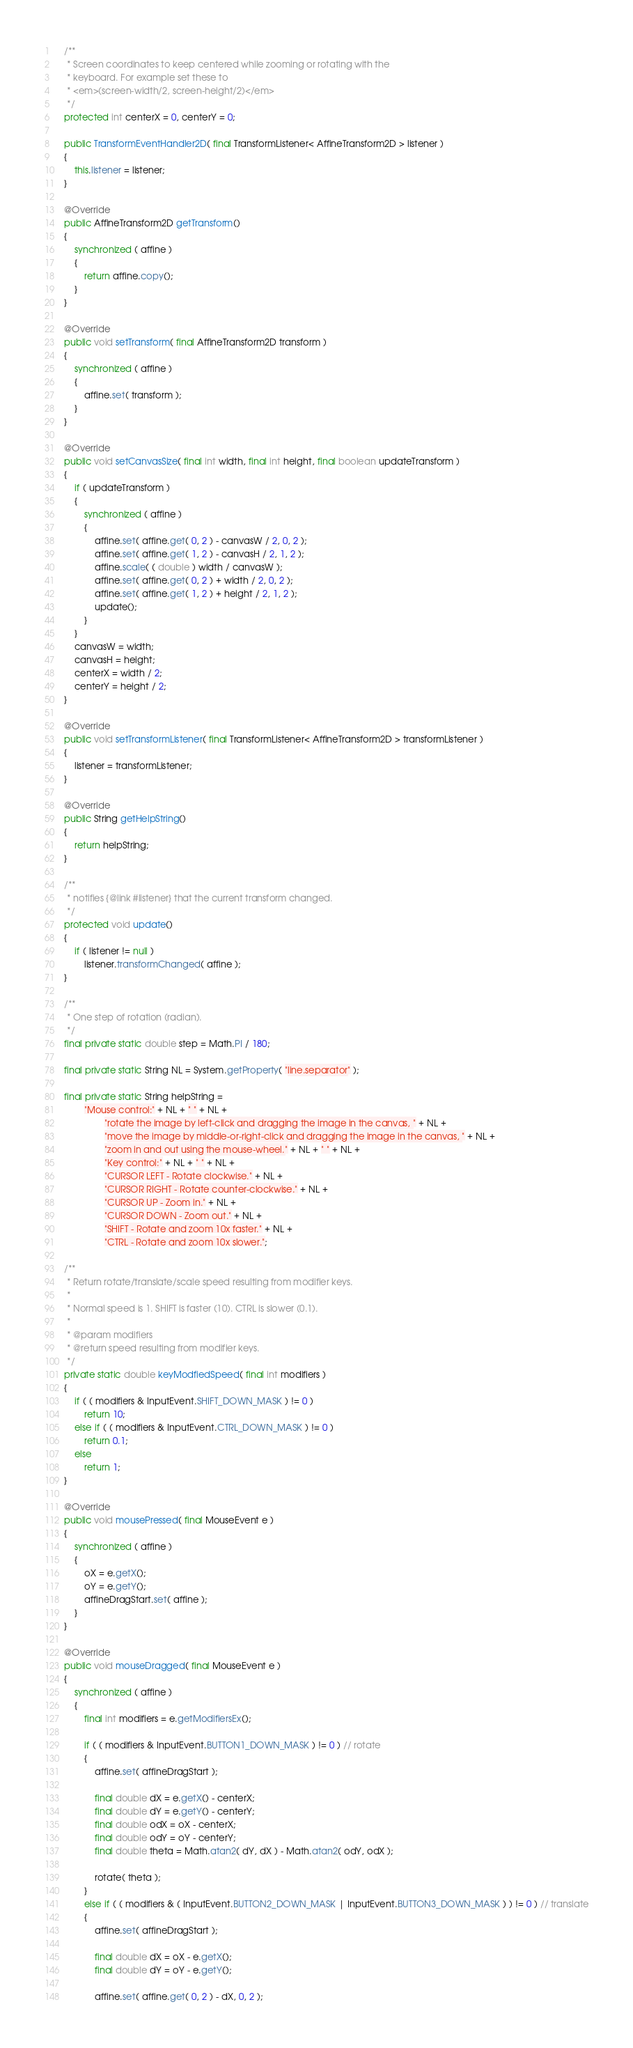Convert code to text. <code><loc_0><loc_0><loc_500><loc_500><_Java_>	/**
	 * Screen coordinates to keep centered while zooming or rotating with the
	 * keyboard. For example set these to
	 * <em>(screen-width/2, screen-height/2)</em>
	 */
	protected int centerX = 0, centerY = 0;

	public TransformEventHandler2D( final TransformListener< AffineTransform2D > listener )
	{
		this.listener = listener;
	}

	@Override
	public AffineTransform2D getTransform()
	{
		synchronized ( affine )
		{
			return affine.copy();
		}
	}

	@Override
	public void setTransform( final AffineTransform2D transform )
	{
		synchronized ( affine )
		{
			affine.set( transform );
		}
	}

	@Override
	public void setCanvasSize( final int width, final int height, final boolean updateTransform )
	{
		if ( updateTransform )
		{
			synchronized ( affine )
			{
				affine.set( affine.get( 0, 2 ) - canvasW / 2, 0, 2 );
				affine.set( affine.get( 1, 2 ) - canvasH / 2, 1, 2 );
				affine.scale( ( double ) width / canvasW );
				affine.set( affine.get( 0, 2 ) + width / 2, 0, 2 );
				affine.set( affine.get( 1, 2 ) + height / 2, 1, 2 );
				update();
			}
		}
		canvasW = width;
		canvasH = height;
		centerX = width / 2;
		centerY = height / 2;
	}

	@Override
	public void setTransformListener( final TransformListener< AffineTransform2D > transformListener )
	{
		listener = transformListener;
	}

	@Override
	public String getHelpString()
	{
		return helpString;
	}

	/**
	 * notifies {@link #listener} that the current transform changed.
	 */
	protected void update()
	{
		if ( listener != null )
			listener.transformChanged( affine );
	}

	/**
	 * One step of rotation (radian).
	 */
	final private static double step = Math.PI / 180;

	final private static String NL = System.getProperty( "line.separator" );

	final private static String helpString =
			"Mouse control:" + NL + " " + NL +
					"rotate the image by left-click and dragging the image in the canvas, " + NL +
					"move the image by middle-or-right-click and dragging the image in the canvas, " + NL +
					"zoom in and out using the mouse-wheel." + NL + " " + NL +
					"Key control:" + NL + " " + NL +
					"CURSOR LEFT - Rotate clockwise." + NL +
					"CURSOR RIGHT - Rotate counter-clockwise." + NL +
					"CURSOR UP - Zoom in." + NL +
					"CURSOR DOWN - Zoom out." + NL +
					"SHIFT - Rotate and zoom 10x faster." + NL +
					"CTRL - Rotate and zoom 10x slower.";

	/**
	 * Return rotate/translate/scale speed resulting from modifier keys.
	 * 
	 * Normal speed is 1. SHIFT is faster (10). CTRL is slower (0.1).
	 * 
	 * @param modifiers
	 * @return speed resulting from modifier keys.
	 */
	private static double keyModfiedSpeed( final int modifiers )
	{
		if ( ( modifiers & InputEvent.SHIFT_DOWN_MASK ) != 0 )
			return 10;
		else if ( ( modifiers & InputEvent.CTRL_DOWN_MASK ) != 0 )
			return 0.1;
		else
			return 1;
	}

	@Override
	public void mousePressed( final MouseEvent e )
	{
		synchronized ( affine )
		{
			oX = e.getX();
			oY = e.getY();
			affineDragStart.set( affine );
		}
	}

	@Override
	public void mouseDragged( final MouseEvent e )
	{
		synchronized ( affine )
		{
			final int modifiers = e.getModifiersEx();

			if ( ( modifiers & InputEvent.BUTTON1_DOWN_MASK ) != 0 ) // rotate
			{
				affine.set( affineDragStart );

				final double dX = e.getX() - centerX;
				final double dY = e.getY() - centerY;
				final double odX = oX - centerX;
				final double odY = oY - centerY;
				final double theta = Math.atan2( dY, dX ) - Math.atan2( odY, odX );

				rotate( theta );
			}
			else if ( ( modifiers & ( InputEvent.BUTTON2_DOWN_MASK | InputEvent.BUTTON3_DOWN_MASK ) ) != 0 ) // translate
			{
				affine.set( affineDragStart );

				final double dX = oX - e.getX();
				final double dY = oY - e.getY();

				affine.set( affine.get( 0, 2 ) - dX, 0, 2 );</code> 